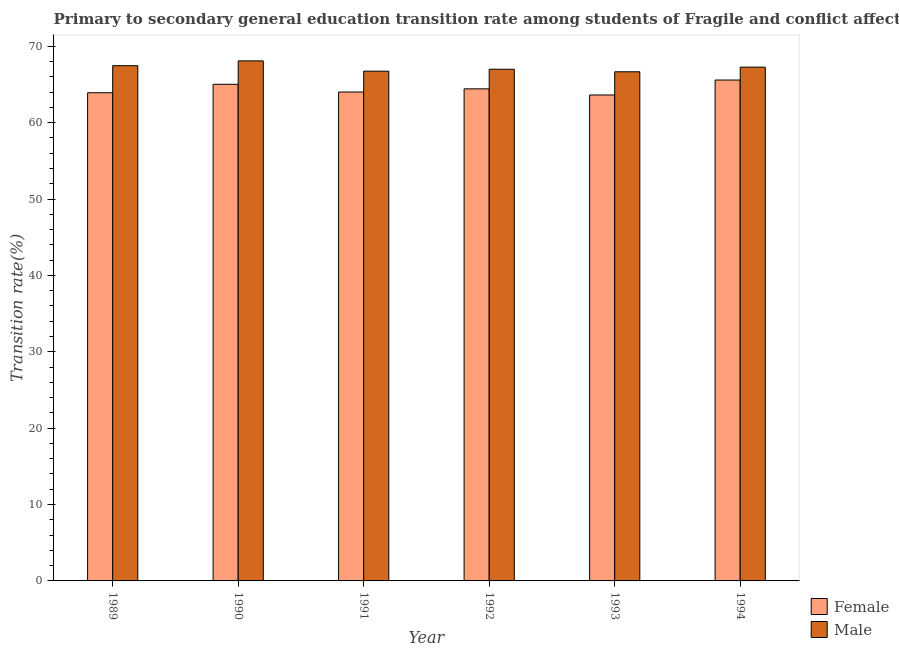Are the number of bars per tick equal to the number of legend labels?
Your answer should be compact. Yes. Are the number of bars on each tick of the X-axis equal?
Keep it short and to the point. Yes. In how many cases, is the number of bars for a given year not equal to the number of legend labels?
Give a very brief answer. 0. What is the transition rate among female students in 1992?
Provide a short and direct response. 64.42. Across all years, what is the maximum transition rate among female students?
Your answer should be very brief. 65.58. Across all years, what is the minimum transition rate among male students?
Your response must be concise. 66.66. In which year was the transition rate among female students maximum?
Offer a very short reply. 1994. In which year was the transition rate among female students minimum?
Provide a succinct answer. 1993. What is the total transition rate among male students in the graph?
Your answer should be very brief. 403.18. What is the difference between the transition rate among male students in 1989 and that in 1992?
Give a very brief answer. 0.46. What is the difference between the transition rate among female students in 1994 and the transition rate among male students in 1991?
Your answer should be compact. 1.57. What is the average transition rate among female students per year?
Keep it short and to the point. 64.43. In how many years, is the transition rate among male students greater than 26 %?
Offer a very short reply. 6. What is the ratio of the transition rate among male students in 1989 to that in 1993?
Your answer should be very brief. 1.01. Is the difference between the transition rate among male students in 1991 and 1993 greater than the difference between the transition rate among female students in 1991 and 1993?
Ensure brevity in your answer.  No. What is the difference between the highest and the second highest transition rate among female students?
Provide a short and direct response. 0.56. What is the difference between the highest and the lowest transition rate among female students?
Give a very brief answer. 1.96. What does the 1st bar from the left in 1994 represents?
Offer a very short reply. Female. How many bars are there?
Keep it short and to the point. 12. Are all the bars in the graph horizontal?
Offer a terse response. No. What is the difference between two consecutive major ticks on the Y-axis?
Your response must be concise. 10. How many legend labels are there?
Provide a succinct answer. 2. What is the title of the graph?
Provide a short and direct response. Primary to secondary general education transition rate among students of Fragile and conflict affected situations. What is the label or title of the Y-axis?
Your answer should be very brief. Transition rate(%). What is the Transition rate(%) in Female in 1989?
Provide a short and direct response. 63.91. What is the Transition rate(%) in Male in 1989?
Ensure brevity in your answer.  67.45. What is the Transition rate(%) in Female in 1990?
Provide a short and direct response. 65.02. What is the Transition rate(%) in Male in 1990?
Give a very brief answer. 68.08. What is the Transition rate(%) of Female in 1991?
Offer a terse response. 64. What is the Transition rate(%) in Male in 1991?
Give a very brief answer. 66.74. What is the Transition rate(%) in Female in 1992?
Ensure brevity in your answer.  64.42. What is the Transition rate(%) in Male in 1992?
Give a very brief answer. 66.99. What is the Transition rate(%) of Female in 1993?
Ensure brevity in your answer.  63.62. What is the Transition rate(%) of Male in 1993?
Provide a succinct answer. 66.66. What is the Transition rate(%) of Female in 1994?
Your answer should be compact. 65.58. What is the Transition rate(%) in Male in 1994?
Provide a short and direct response. 67.26. Across all years, what is the maximum Transition rate(%) of Female?
Your answer should be very brief. 65.58. Across all years, what is the maximum Transition rate(%) in Male?
Give a very brief answer. 68.08. Across all years, what is the minimum Transition rate(%) of Female?
Make the answer very short. 63.62. Across all years, what is the minimum Transition rate(%) in Male?
Your answer should be compact. 66.66. What is the total Transition rate(%) in Female in the graph?
Provide a short and direct response. 386.55. What is the total Transition rate(%) in Male in the graph?
Make the answer very short. 403.18. What is the difference between the Transition rate(%) in Female in 1989 and that in 1990?
Offer a very short reply. -1.11. What is the difference between the Transition rate(%) of Male in 1989 and that in 1990?
Your response must be concise. -0.63. What is the difference between the Transition rate(%) of Female in 1989 and that in 1991?
Your answer should be very brief. -0.09. What is the difference between the Transition rate(%) of Male in 1989 and that in 1991?
Provide a short and direct response. 0.72. What is the difference between the Transition rate(%) in Female in 1989 and that in 1992?
Offer a terse response. -0.51. What is the difference between the Transition rate(%) of Male in 1989 and that in 1992?
Offer a very short reply. 0.46. What is the difference between the Transition rate(%) of Female in 1989 and that in 1993?
Offer a terse response. 0.29. What is the difference between the Transition rate(%) in Male in 1989 and that in 1993?
Offer a terse response. 0.8. What is the difference between the Transition rate(%) of Female in 1989 and that in 1994?
Your answer should be very brief. -1.67. What is the difference between the Transition rate(%) in Male in 1989 and that in 1994?
Provide a short and direct response. 0.19. What is the difference between the Transition rate(%) in Female in 1990 and that in 1991?
Provide a succinct answer. 1.02. What is the difference between the Transition rate(%) in Male in 1990 and that in 1991?
Ensure brevity in your answer.  1.35. What is the difference between the Transition rate(%) of Female in 1990 and that in 1992?
Offer a terse response. 0.6. What is the difference between the Transition rate(%) of Male in 1990 and that in 1992?
Keep it short and to the point. 1.1. What is the difference between the Transition rate(%) of Female in 1990 and that in 1993?
Keep it short and to the point. 1.4. What is the difference between the Transition rate(%) in Male in 1990 and that in 1993?
Keep it short and to the point. 1.43. What is the difference between the Transition rate(%) of Female in 1990 and that in 1994?
Offer a terse response. -0.56. What is the difference between the Transition rate(%) in Male in 1990 and that in 1994?
Make the answer very short. 0.82. What is the difference between the Transition rate(%) of Female in 1991 and that in 1992?
Make the answer very short. -0.42. What is the difference between the Transition rate(%) of Male in 1991 and that in 1992?
Give a very brief answer. -0.25. What is the difference between the Transition rate(%) of Female in 1991 and that in 1993?
Your response must be concise. 0.38. What is the difference between the Transition rate(%) in Male in 1991 and that in 1993?
Make the answer very short. 0.08. What is the difference between the Transition rate(%) in Female in 1991 and that in 1994?
Offer a very short reply. -1.57. What is the difference between the Transition rate(%) in Male in 1991 and that in 1994?
Offer a terse response. -0.53. What is the difference between the Transition rate(%) of Female in 1992 and that in 1993?
Make the answer very short. 0.8. What is the difference between the Transition rate(%) of Male in 1992 and that in 1993?
Keep it short and to the point. 0.33. What is the difference between the Transition rate(%) in Female in 1992 and that in 1994?
Ensure brevity in your answer.  -1.16. What is the difference between the Transition rate(%) of Male in 1992 and that in 1994?
Your response must be concise. -0.27. What is the difference between the Transition rate(%) in Female in 1993 and that in 1994?
Provide a succinct answer. -1.96. What is the difference between the Transition rate(%) in Male in 1993 and that in 1994?
Your answer should be very brief. -0.61. What is the difference between the Transition rate(%) of Female in 1989 and the Transition rate(%) of Male in 1990?
Offer a very short reply. -4.17. What is the difference between the Transition rate(%) of Female in 1989 and the Transition rate(%) of Male in 1991?
Keep it short and to the point. -2.83. What is the difference between the Transition rate(%) of Female in 1989 and the Transition rate(%) of Male in 1992?
Give a very brief answer. -3.08. What is the difference between the Transition rate(%) of Female in 1989 and the Transition rate(%) of Male in 1993?
Provide a succinct answer. -2.74. What is the difference between the Transition rate(%) in Female in 1989 and the Transition rate(%) in Male in 1994?
Provide a succinct answer. -3.35. What is the difference between the Transition rate(%) of Female in 1990 and the Transition rate(%) of Male in 1991?
Your answer should be compact. -1.72. What is the difference between the Transition rate(%) of Female in 1990 and the Transition rate(%) of Male in 1992?
Make the answer very short. -1.97. What is the difference between the Transition rate(%) of Female in 1990 and the Transition rate(%) of Male in 1993?
Offer a terse response. -1.64. What is the difference between the Transition rate(%) of Female in 1990 and the Transition rate(%) of Male in 1994?
Offer a very short reply. -2.24. What is the difference between the Transition rate(%) of Female in 1991 and the Transition rate(%) of Male in 1992?
Give a very brief answer. -2.98. What is the difference between the Transition rate(%) in Female in 1991 and the Transition rate(%) in Male in 1993?
Make the answer very short. -2.65. What is the difference between the Transition rate(%) in Female in 1991 and the Transition rate(%) in Male in 1994?
Ensure brevity in your answer.  -3.26. What is the difference between the Transition rate(%) of Female in 1992 and the Transition rate(%) of Male in 1993?
Provide a succinct answer. -2.23. What is the difference between the Transition rate(%) in Female in 1992 and the Transition rate(%) in Male in 1994?
Your answer should be compact. -2.84. What is the difference between the Transition rate(%) of Female in 1993 and the Transition rate(%) of Male in 1994?
Provide a short and direct response. -3.64. What is the average Transition rate(%) of Female per year?
Keep it short and to the point. 64.43. What is the average Transition rate(%) in Male per year?
Provide a short and direct response. 67.2. In the year 1989, what is the difference between the Transition rate(%) of Female and Transition rate(%) of Male?
Your answer should be very brief. -3.54. In the year 1990, what is the difference between the Transition rate(%) of Female and Transition rate(%) of Male?
Make the answer very short. -3.06. In the year 1991, what is the difference between the Transition rate(%) of Female and Transition rate(%) of Male?
Your answer should be very brief. -2.73. In the year 1992, what is the difference between the Transition rate(%) in Female and Transition rate(%) in Male?
Give a very brief answer. -2.57. In the year 1993, what is the difference between the Transition rate(%) in Female and Transition rate(%) in Male?
Make the answer very short. -3.04. In the year 1994, what is the difference between the Transition rate(%) of Female and Transition rate(%) of Male?
Keep it short and to the point. -1.68. What is the ratio of the Transition rate(%) of Female in 1989 to that in 1990?
Your response must be concise. 0.98. What is the ratio of the Transition rate(%) in Male in 1989 to that in 1990?
Provide a short and direct response. 0.99. What is the ratio of the Transition rate(%) of Female in 1989 to that in 1991?
Keep it short and to the point. 1. What is the ratio of the Transition rate(%) of Male in 1989 to that in 1991?
Provide a short and direct response. 1.01. What is the ratio of the Transition rate(%) of Female in 1989 to that in 1992?
Provide a short and direct response. 0.99. What is the ratio of the Transition rate(%) in Male in 1989 to that in 1992?
Your answer should be compact. 1.01. What is the ratio of the Transition rate(%) in Male in 1989 to that in 1993?
Your response must be concise. 1.01. What is the ratio of the Transition rate(%) of Female in 1989 to that in 1994?
Your answer should be compact. 0.97. What is the ratio of the Transition rate(%) in Male in 1989 to that in 1994?
Your answer should be compact. 1. What is the ratio of the Transition rate(%) in Female in 1990 to that in 1991?
Offer a very short reply. 1.02. What is the ratio of the Transition rate(%) in Male in 1990 to that in 1991?
Your answer should be compact. 1.02. What is the ratio of the Transition rate(%) in Female in 1990 to that in 1992?
Offer a terse response. 1.01. What is the ratio of the Transition rate(%) of Male in 1990 to that in 1992?
Ensure brevity in your answer.  1.02. What is the ratio of the Transition rate(%) of Female in 1990 to that in 1993?
Provide a short and direct response. 1.02. What is the ratio of the Transition rate(%) of Male in 1990 to that in 1993?
Offer a terse response. 1.02. What is the ratio of the Transition rate(%) of Male in 1990 to that in 1994?
Provide a short and direct response. 1.01. What is the ratio of the Transition rate(%) of Female in 1991 to that in 1992?
Your answer should be very brief. 0.99. What is the ratio of the Transition rate(%) in Male in 1991 to that in 1992?
Your answer should be very brief. 1. What is the ratio of the Transition rate(%) in Male in 1991 to that in 1993?
Give a very brief answer. 1. What is the ratio of the Transition rate(%) of Female in 1992 to that in 1993?
Give a very brief answer. 1.01. What is the ratio of the Transition rate(%) in Female in 1992 to that in 1994?
Make the answer very short. 0.98. What is the ratio of the Transition rate(%) in Male in 1992 to that in 1994?
Your answer should be compact. 1. What is the ratio of the Transition rate(%) in Female in 1993 to that in 1994?
Make the answer very short. 0.97. What is the difference between the highest and the second highest Transition rate(%) of Female?
Offer a terse response. 0.56. What is the difference between the highest and the second highest Transition rate(%) in Male?
Your response must be concise. 0.63. What is the difference between the highest and the lowest Transition rate(%) of Female?
Ensure brevity in your answer.  1.96. What is the difference between the highest and the lowest Transition rate(%) of Male?
Offer a terse response. 1.43. 